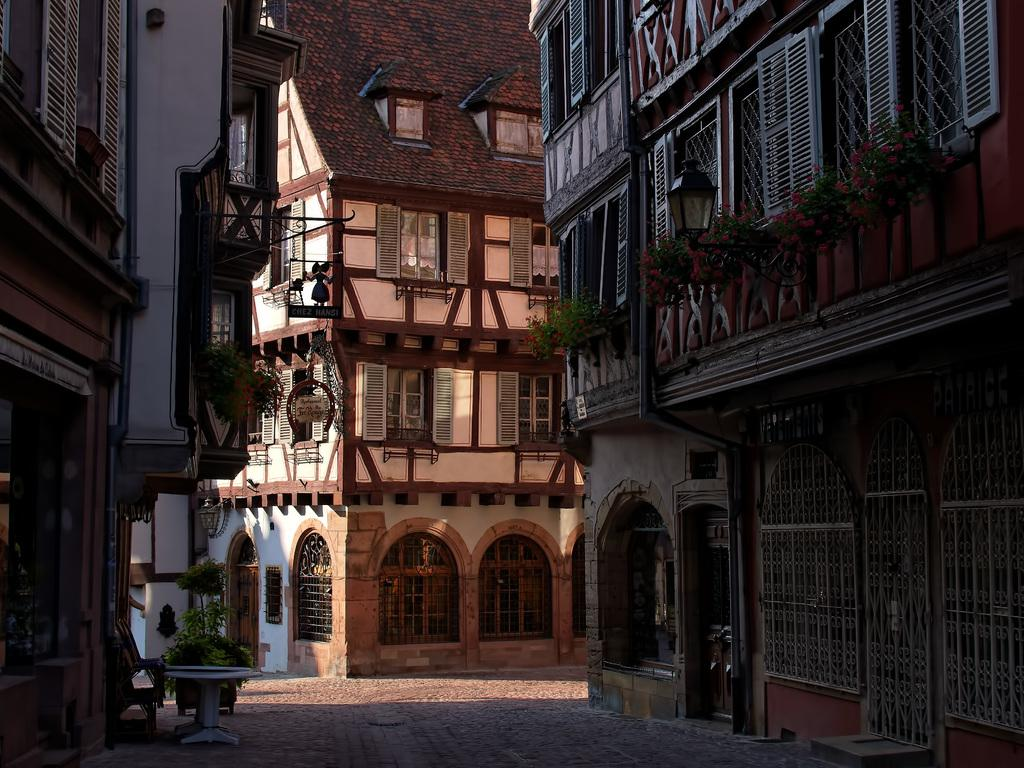What type of structures can be seen in the image? There are buildings in the image. What feature is visible on the buildings? There are windows visible in the image. What type of vegetation is present in the image? There are plants in the image. What else can be seen on the ground in the image? There are other objects on the ground in the image. What type of lipstick is the society wearing in the image? There is no lipstick or society present in the image; it features buildings, windows, plants, and other objects on the ground. 